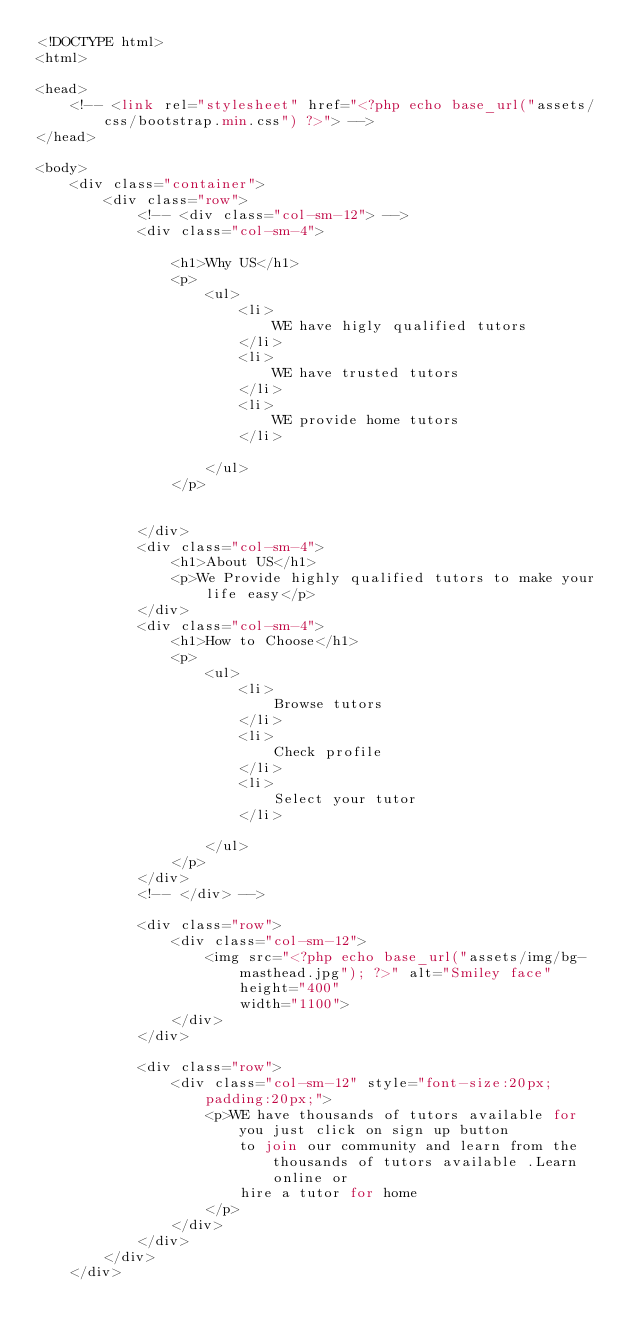Convert code to text. <code><loc_0><loc_0><loc_500><loc_500><_PHP_><!DOCTYPE html>
<html>

<head>
    <!-- <link rel="stylesheet" href="<?php echo base_url("assets/css/bootstrap.min.css") ?>"> -->
</head>

<body>
    <div class="container">
        <div class="row">
            <!-- <div class="col-sm-12"> -->
            <div class="col-sm-4">

                <h1>Why US</h1>
                <p>
                    <ul>
                        <li>
                            WE have higly qualified tutors
                        </li>
                        <li>
                            WE have trusted tutors
                        </li>
                        <li>
                            WE provide home tutors
                        </li>

                    </ul>
                </p>


            </div>
            <div class="col-sm-4">
                <h1>About US</h1>
                <p>We Provide highly qualified tutors to make your life easy</p>
            </div>
            <div class="col-sm-4">
                <h1>How to Choose</h1>
                <p>
                    <ul>
                        <li>
                            Browse tutors
                        </li>
                        <li>
                            Check profile
                        </li>
                        <li>
                            Select your tutor
                        </li>

                    </ul>
                </p>
            </div>
            <!-- </div> -->

            <div class="row">
                <div class="col-sm-12">
                    <img src="<?php echo base_url("assets/img/bg-masthead.jpg"); ?>" alt="Smiley face" height="400"
                        width="1100">
                </div>
            </div>

            <div class="row">
                <div class="col-sm-12" style="font-size:20px;padding:20px;">
                    <p>WE have thousands of tutors available for you just click on sign up button
                        to join our community and learn from the thousands of tutors available .Learn online or
                        hire a tutor for home
                    </p>
                </div>
            </div>
        </div>
    </div></code> 